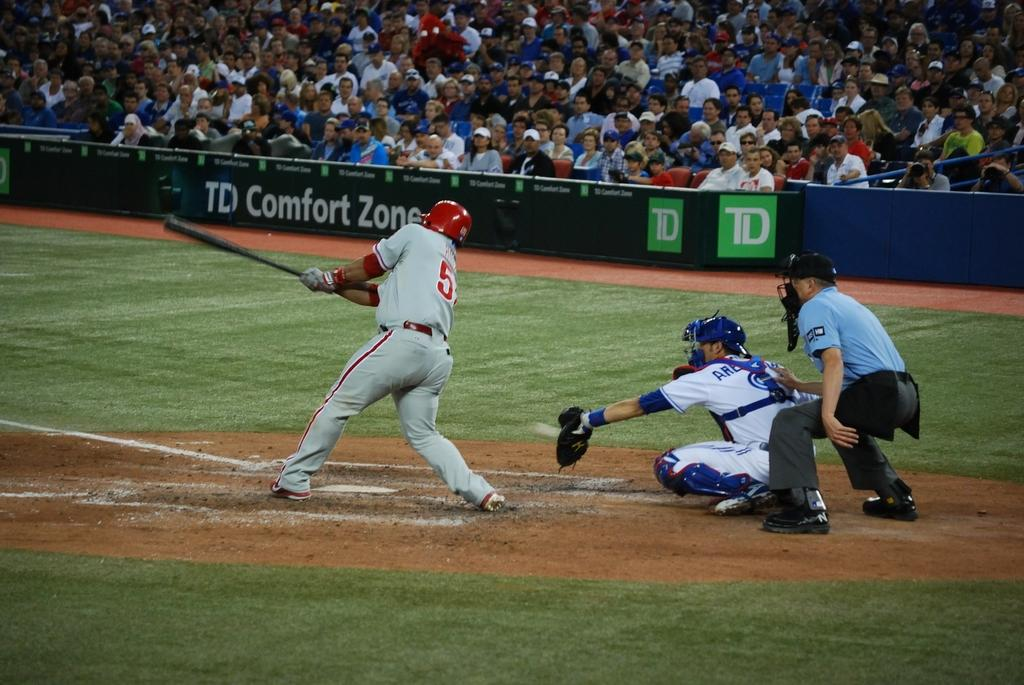<image>
Relay a brief, clear account of the picture shown. Swing and a miss with a TD Comfort Zone sign on the field. 